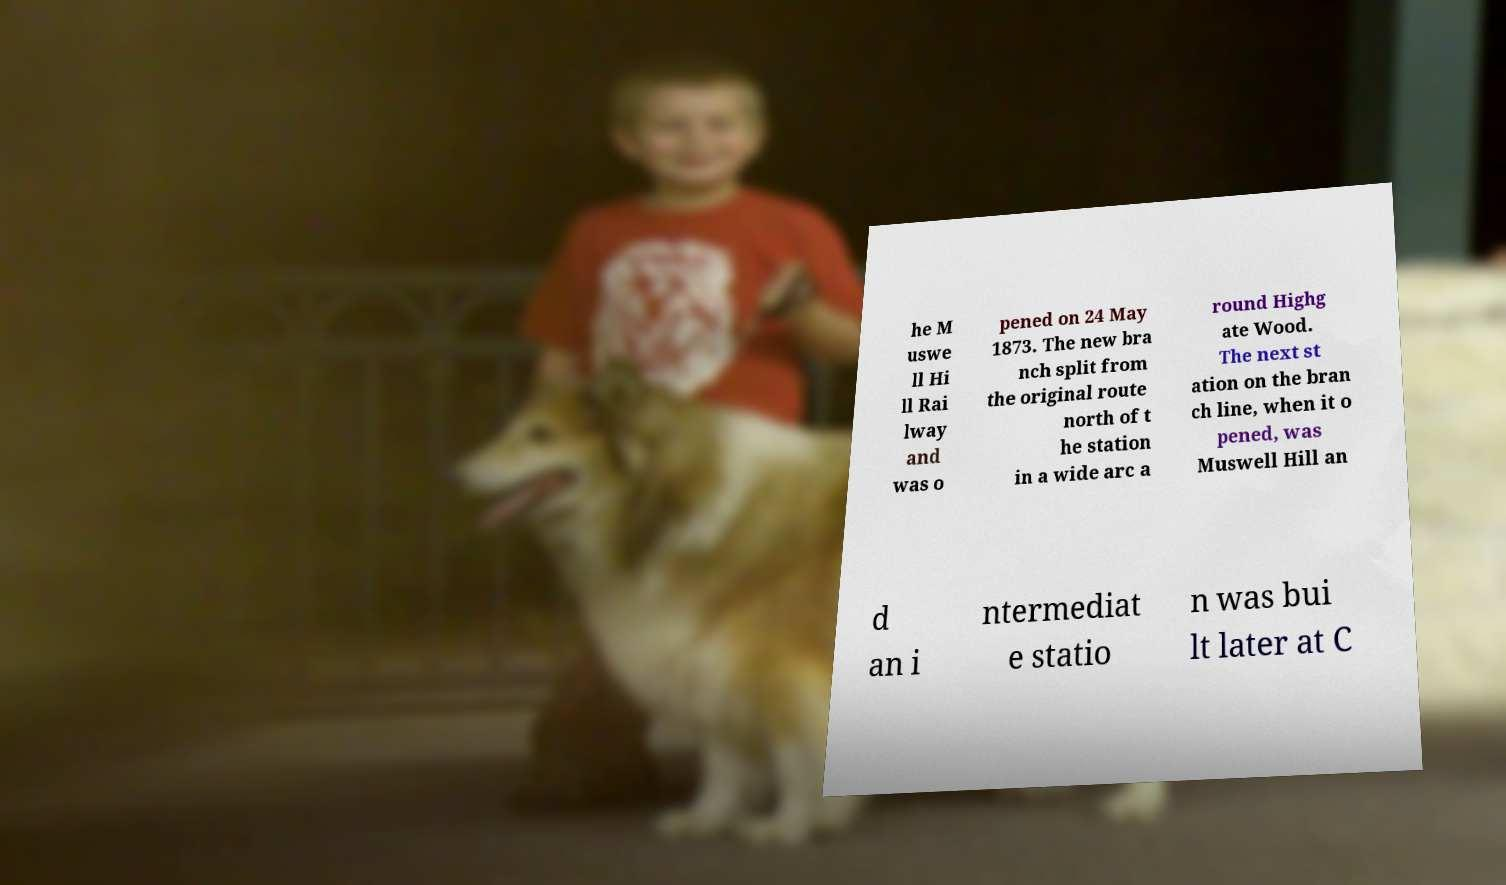I need the written content from this picture converted into text. Can you do that? he M uswe ll Hi ll Rai lway and was o pened on 24 May 1873. The new bra nch split from the original route north of t he station in a wide arc a round Highg ate Wood. The next st ation on the bran ch line, when it o pened, was Muswell Hill an d an i ntermediat e statio n was bui lt later at C 